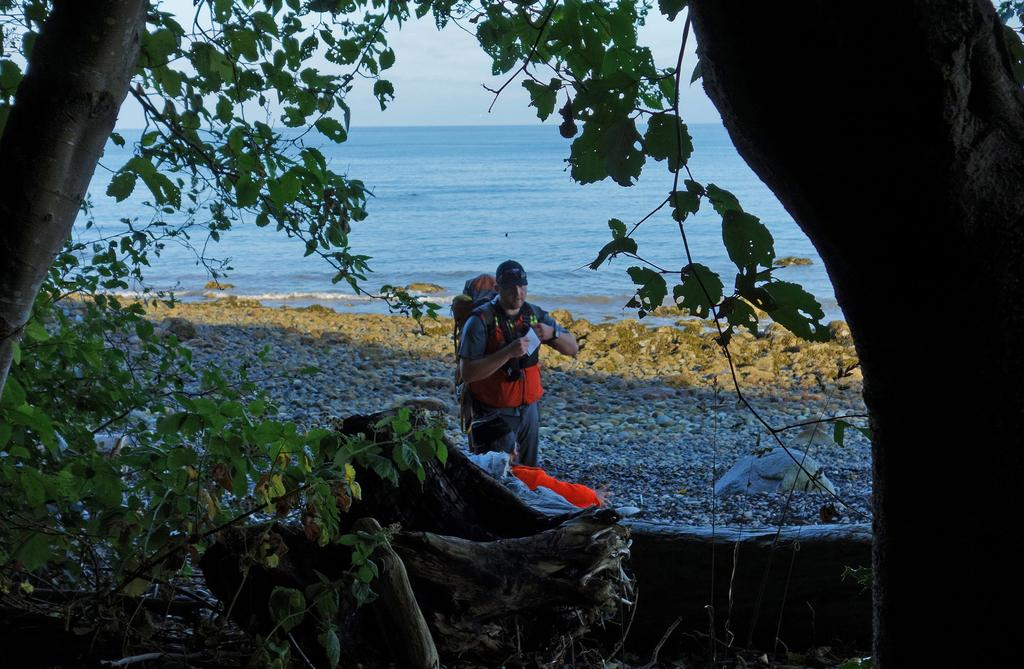What type of natural elements can be seen in the image? There are branches and leaves in the image. Can you describe the people in the image? There are people in the image, and one of them is wearing a bag. What other objects or features are present in the image? There are rocks, water, and sky visible in the image. Additionally, one person is holding an object. What type of waste can be seen in the image? There is no waste present in the image. Can you describe the scarecrow in the image? There is no scarecrow present in the image. 